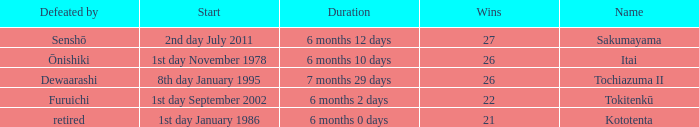Which Start has a Duration of 6 months 2 days? 1st day September 2002. 